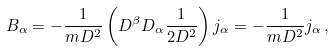Convert formula to latex. <formula><loc_0><loc_0><loc_500><loc_500>B _ { \alpha } = - \frac { 1 } { m D ^ { 2 } } \left ( D ^ { \beta } D _ { \alpha } \frac { 1 } { 2 D ^ { 2 } } \right ) j _ { \alpha } = - \frac { 1 } { m D ^ { 2 } } j _ { \alpha } \, ,</formula> 